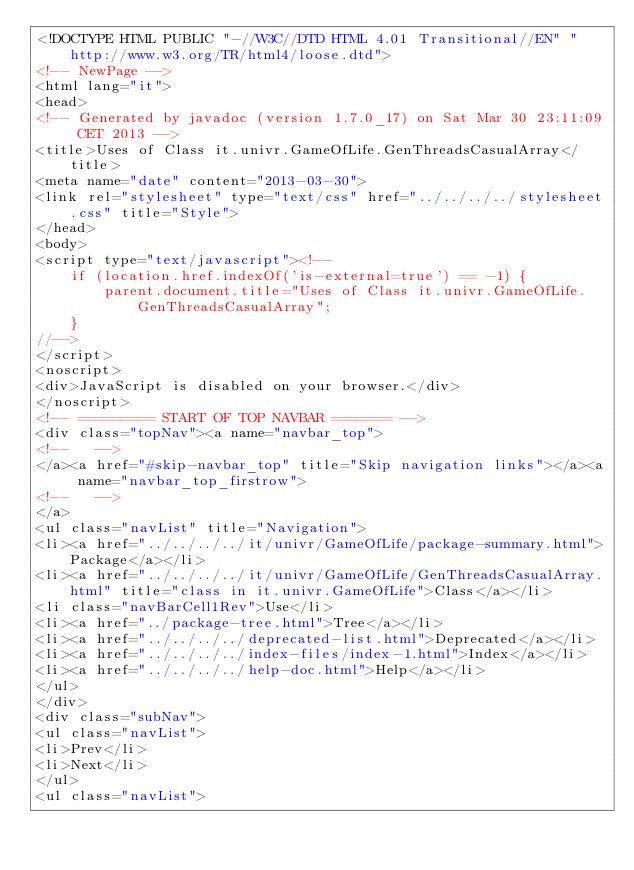Convert code to text. <code><loc_0><loc_0><loc_500><loc_500><_HTML_><!DOCTYPE HTML PUBLIC "-//W3C//DTD HTML 4.01 Transitional//EN" "http://www.w3.org/TR/html4/loose.dtd">
<!-- NewPage -->
<html lang="it">
<head>
<!-- Generated by javadoc (version 1.7.0_17) on Sat Mar 30 23:11:09 CET 2013 -->
<title>Uses of Class it.univr.GameOfLife.GenThreadsCasualArray</title>
<meta name="date" content="2013-03-30">
<link rel="stylesheet" type="text/css" href="../../../../stylesheet.css" title="Style">
</head>
<body>
<script type="text/javascript"><!--
    if (location.href.indexOf('is-external=true') == -1) {
        parent.document.title="Uses of Class it.univr.GameOfLife.GenThreadsCasualArray";
    }
//-->
</script>
<noscript>
<div>JavaScript is disabled on your browser.</div>
</noscript>
<!-- ========= START OF TOP NAVBAR ======= -->
<div class="topNav"><a name="navbar_top">
<!--   -->
</a><a href="#skip-navbar_top" title="Skip navigation links"></a><a name="navbar_top_firstrow">
<!--   -->
</a>
<ul class="navList" title="Navigation">
<li><a href="../../../../it/univr/GameOfLife/package-summary.html">Package</a></li>
<li><a href="../../../../it/univr/GameOfLife/GenThreadsCasualArray.html" title="class in it.univr.GameOfLife">Class</a></li>
<li class="navBarCell1Rev">Use</li>
<li><a href="../package-tree.html">Tree</a></li>
<li><a href="../../../../deprecated-list.html">Deprecated</a></li>
<li><a href="../../../../index-files/index-1.html">Index</a></li>
<li><a href="../../../../help-doc.html">Help</a></li>
</ul>
</div>
<div class="subNav">
<ul class="navList">
<li>Prev</li>
<li>Next</li>
</ul>
<ul class="navList"></code> 